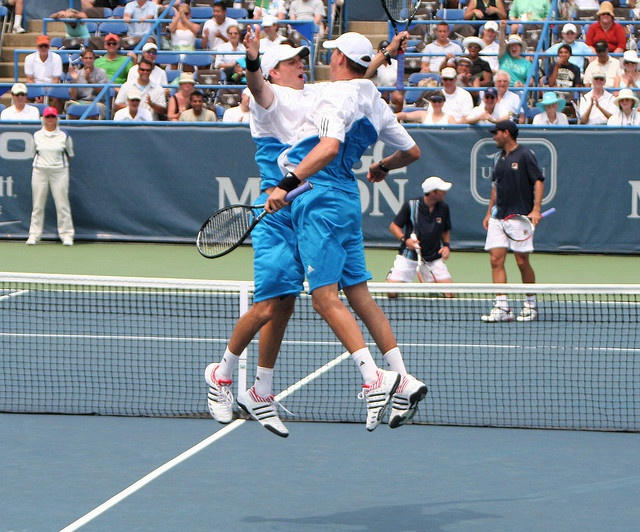Describe the objects in this image and their specific colors. I can see people in gray, lightgray, darkgray, and brown tones, people in gray, lavender, blue, and brown tones, people in gray, lavender, blue, lightblue, and darkgray tones, people in gray, black, lavender, and brown tones, and people in gray, black, lavender, and darkgray tones in this image. 